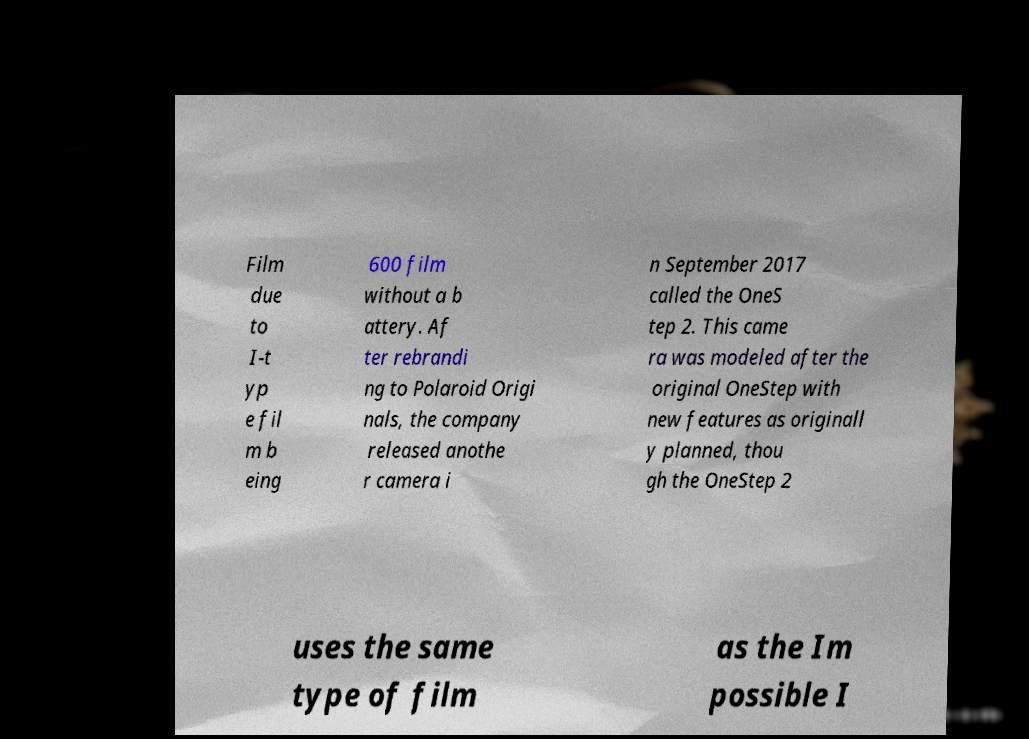I need the written content from this picture converted into text. Can you do that? Film due to I-t yp e fil m b eing 600 film without a b attery. Af ter rebrandi ng to Polaroid Origi nals, the company released anothe r camera i n September 2017 called the OneS tep 2. This came ra was modeled after the original OneStep with new features as originall y planned, thou gh the OneStep 2 uses the same type of film as the Im possible I 